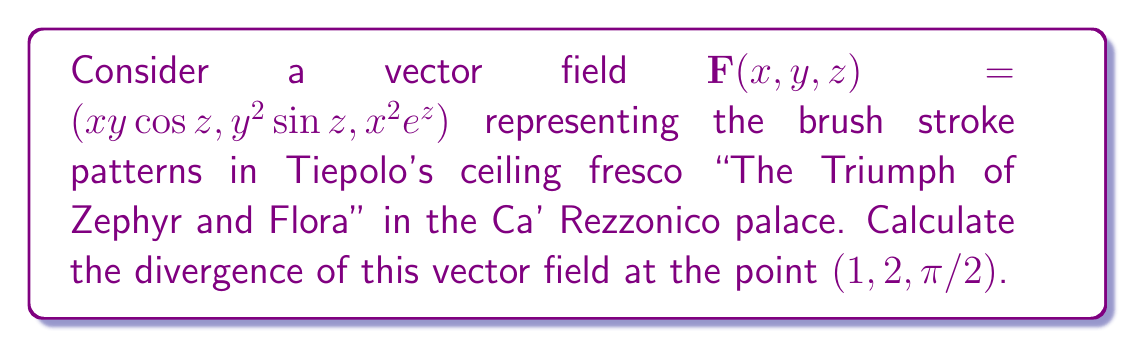Can you solve this math problem? To find the divergence of the vector field $\mathbf{F}(x,y,z) = (xy\cos z, y^2\sin z, x^2e^z)$, we need to calculate:

$$\nabla \cdot \mathbf{F} = \frac{\partial F_x}{\partial x} + \frac{\partial F_y}{\partial y} + \frac{\partial F_z}{\partial z}$$

Let's calculate each partial derivative:

1. $\frac{\partial F_x}{\partial x} = \frac{\partial}{\partial x}(xy\cos z) = y\cos z$

2. $\frac{\partial F_y}{\partial y} = \frac{\partial}{\partial y}(y^2\sin z) = 2y\sin z$

3. $\frac{\partial F_z}{\partial z} = \frac{\partial}{\partial z}(x^2e^z) = x^2e^z$

Now, we substitute these partial derivatives into the divergence formula:

$$\nabla \cdot \mathbf{F} = y\cos z + 2y\sin z + x^2e^z$$

To evaluate this at the point $(1, 2, \pi/2)$, we substitute $x=1$, $y=2$, and $z=\pi/2$:

$$\begin{align*}
\nabla \cdot \mathbf{F}(1,2,\pi/2) &= 2\cos(\pi/2) + 2(2)\sin(\pi/2) + 1^2e^{\pi/2} \\
&= 2(0) + 2(2)(1) + e^{\pi/2} \\
&= 0 + 4 + e^{\pi/2}
\end{align*}$$

Therefore, the divergence of the vector field at $(1, 2, \pi/2)$ is $4 + e^{\pi/2}$.
Answer: $4 + e^{\pi/2}$ 